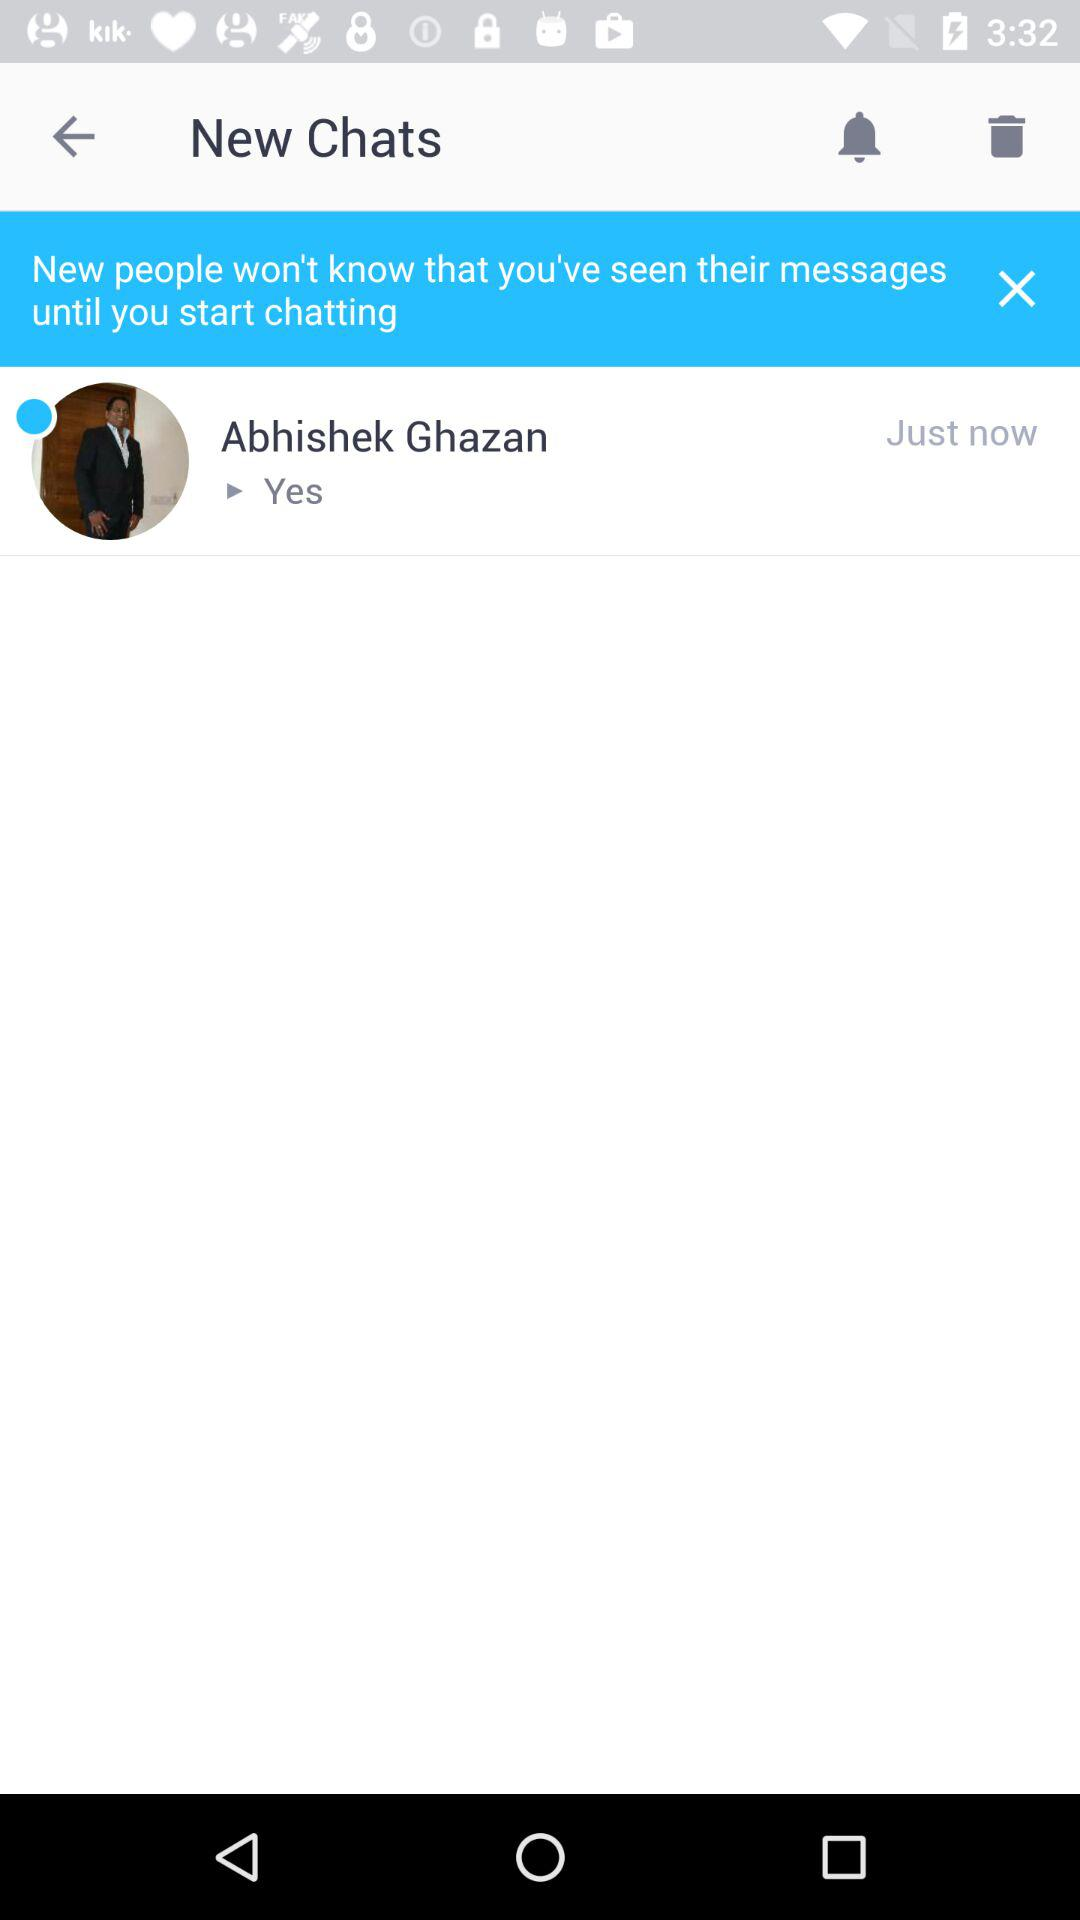How many unread messages does Abhishek Ghazan have?
Answer the question using a single word or phrase. 1 